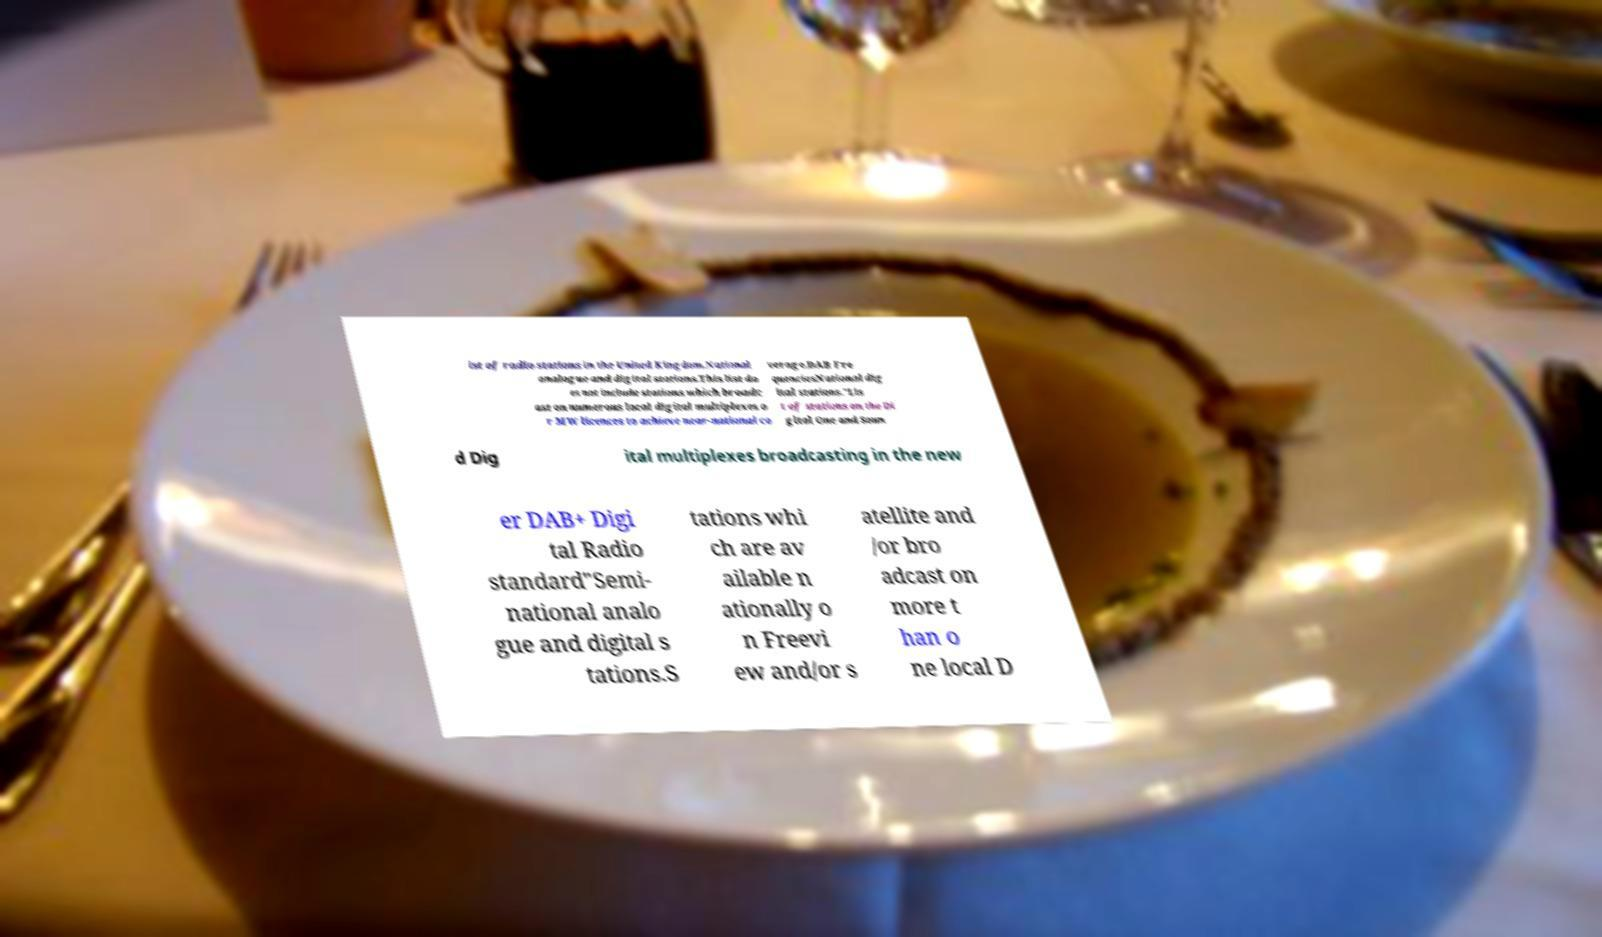Could you extract and type out the text from this image? ist of radio stations in the United Kingdom.National analogue and digital stations.This list do es not include stations which broadc ast on numerous local digital multiplexes o r MW licences to achieve near-national co verage.DAB Fre quenciesNational dig ital stations."Lis t of stations on the Di gital One and Soun d Dig ital multiplexes broadcasting in the new er DAB+ Digi tal Radio standard"Semi- national analo gue and digital s tations.S tations whi ch are av ailable n ationally o n Freevi ew and/or s atellite and /or bro adcast on more t han o ne local D 